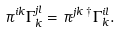<formula> <loc_0><loc_0><loc_500><loc_500>\pi ^ { i k } \Gamma _ { k } ^ { j l } = \pi ^ { j k } \, ^ { \dagger } \Gamma _ { k } ^ { i l } .</formula> 